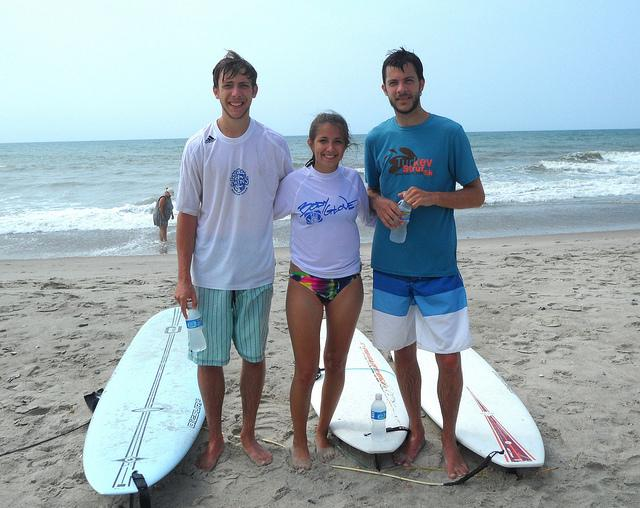How many types of surfboards are there?

Choices:
A) five
B) nine
C) three
D) two three 